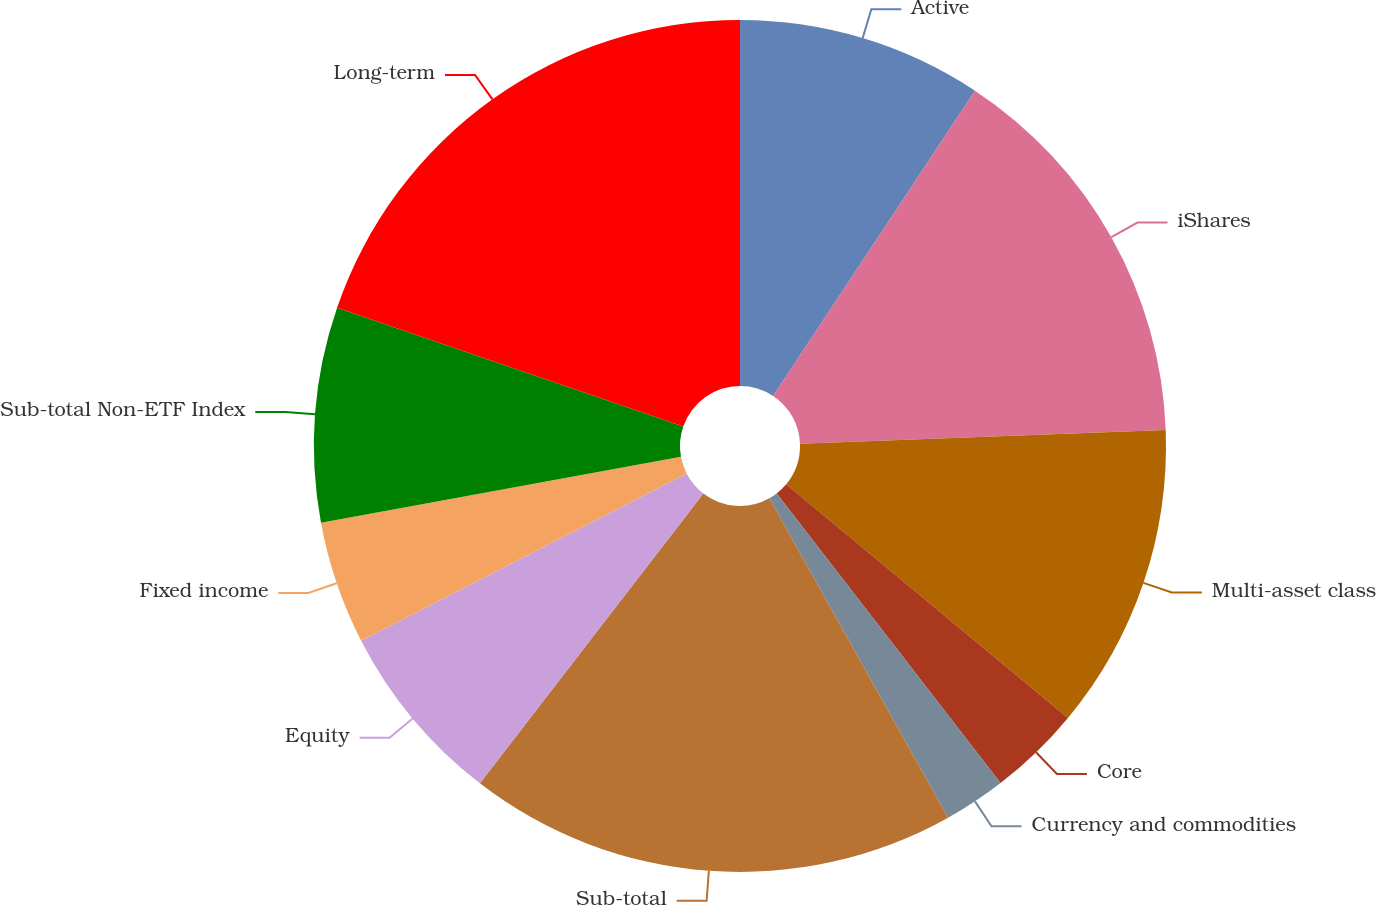Convert chart. <chart><loc_0><loc_0><loc_500><loc_500><pie_chart><fcel>Active<fcel>iShares<fcel>Multi-asset class<fcel>Core<fcel>Currency and commodities<fcel>Sub-total<fcel>Equity<fcel>Fixed income<fcel>Sub-total Non-ETF Index<fcel>Long-term<nl><fcel>9.3%<fcel>15.1%<fcel>11.62%<fcel>3.51%<fcel>2.35%<fcel>18.58%<fcel>6.99%<fcel>4.67%<fcel>8.15%<fcel>19.74%<nl></chart> 